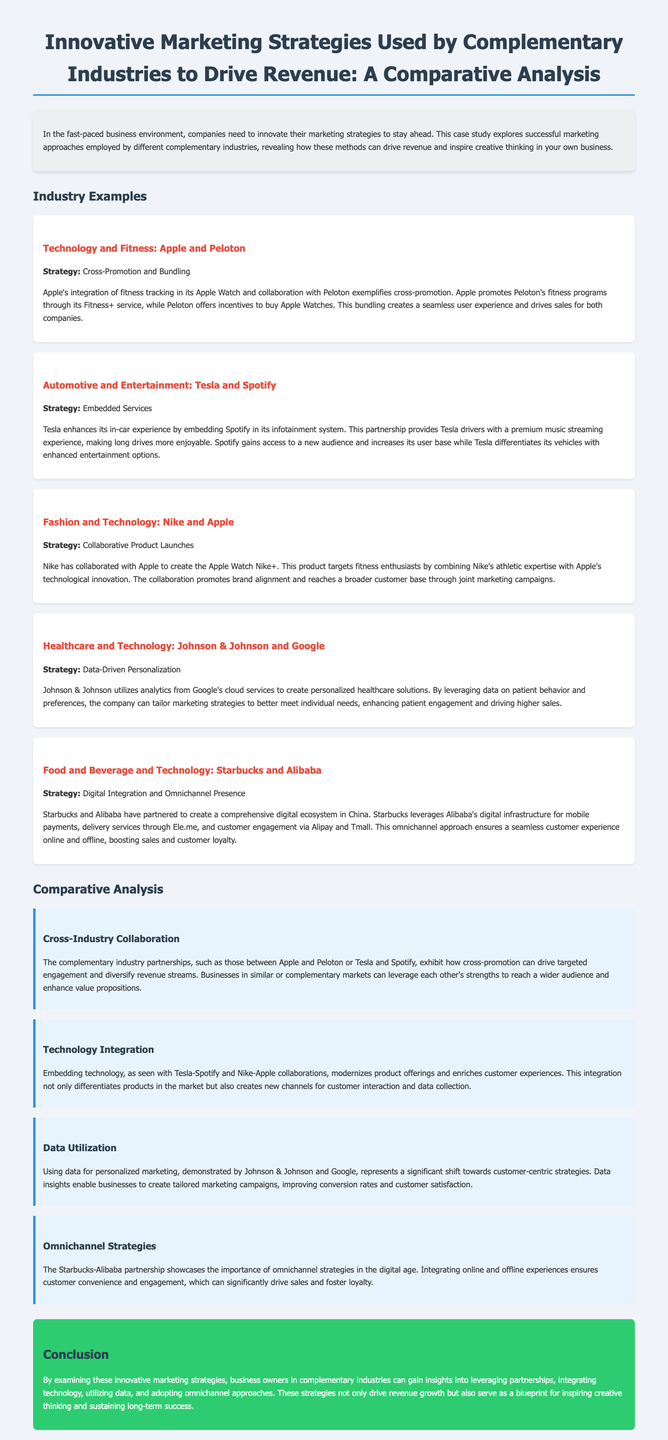What is the title of the case study? The title is explicitly mentioned at the top of the document, detailing the focus on marketing strategies in complementary industries.
Answer: Innovative Marketing Strategies Used by Complementary Industries to Drive Revenue: A Comparative Analysis Who are the two companies involved in the technology and fitness example? The case study lists the partnership between two prominent brands in the hand and fitness industry as part of the marketing strategies explored.
Answer: Apple and Peloton What strategy is highlighted in the healthcare and technology example? The document specifies that Johnson & Johnson and Google utilize a particular method that enhances patient engagement to drive revenue.
Answer: Data-Driven Personalization What type of marketing strategy is exemplified by Starbucks and Alibaba? The document describes the approach these two companies adopt to engage customers through multiple channels, emphasizing its effectiveness in driving sales.
Answer: Digital Integration and Omnichannel Presence How does Tesla enhance its customer experience according to the document? The document illustrates how Tesla increases its value proposition and customer satisfaction through a specific feature integrated into its vehicles.
Answer: Embedded Services What is one significant benefit of data utilization mentioned in the document? The case study discusses the advantages that businesses obtain from applying data insights to their marketing strategies for improved customer experience.
Answer: Personalized marketing campaigns Which industry partnership focuses on cross-promotion? The case study provides insights into partnerships that exemplify effective marketing techniques to enhance outreach for both involved industries.
Answer: Apple and Peloton What is the primary conclusion from the case study? The final section summarizes the key takeaways that business owners can apply to improve their revenue growth strategies.
Answer: Strategies drive revenue growth 